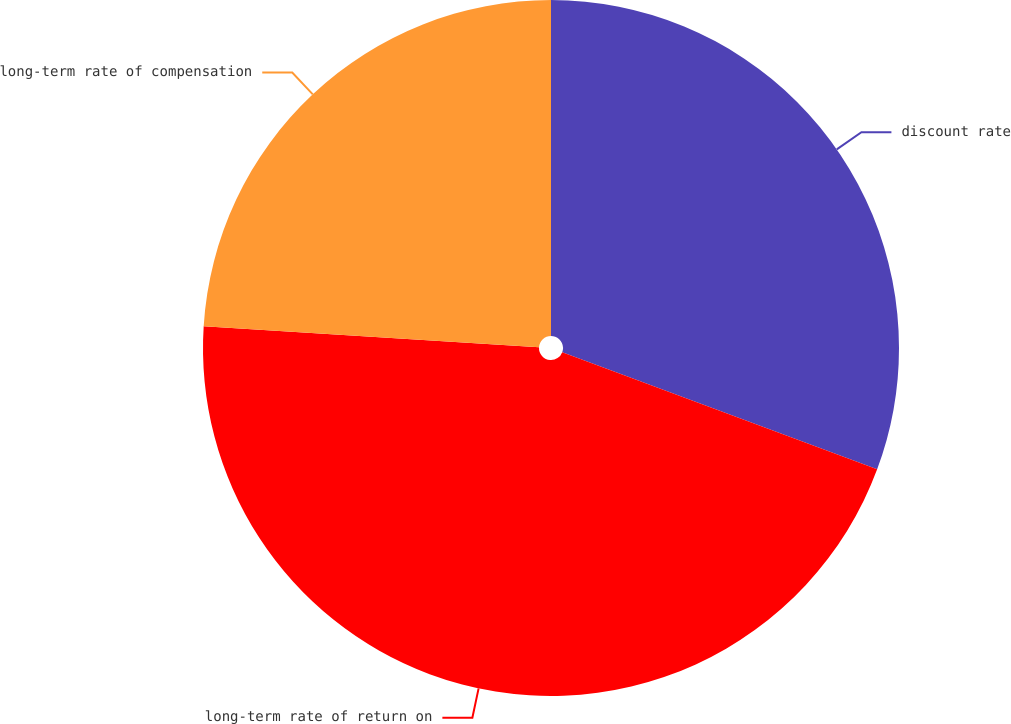<chart> <loc_0><loc_0><loc_500><loc_500><pie_chart><fcel>discount rate<fcel>long-term rate of return on<fcel>long-term rate of compensation<nl><fcel>30.67%<fcel>45.33%<fcel>24.0%<nl></chart> 